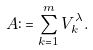Convert formula to latex. <formula><loc_0><loc_0><loc_500><loc_500>A \colon = \sum _ { k = 1 } ^ { m } V _ { k } ^ { \lambda } .</formula> 